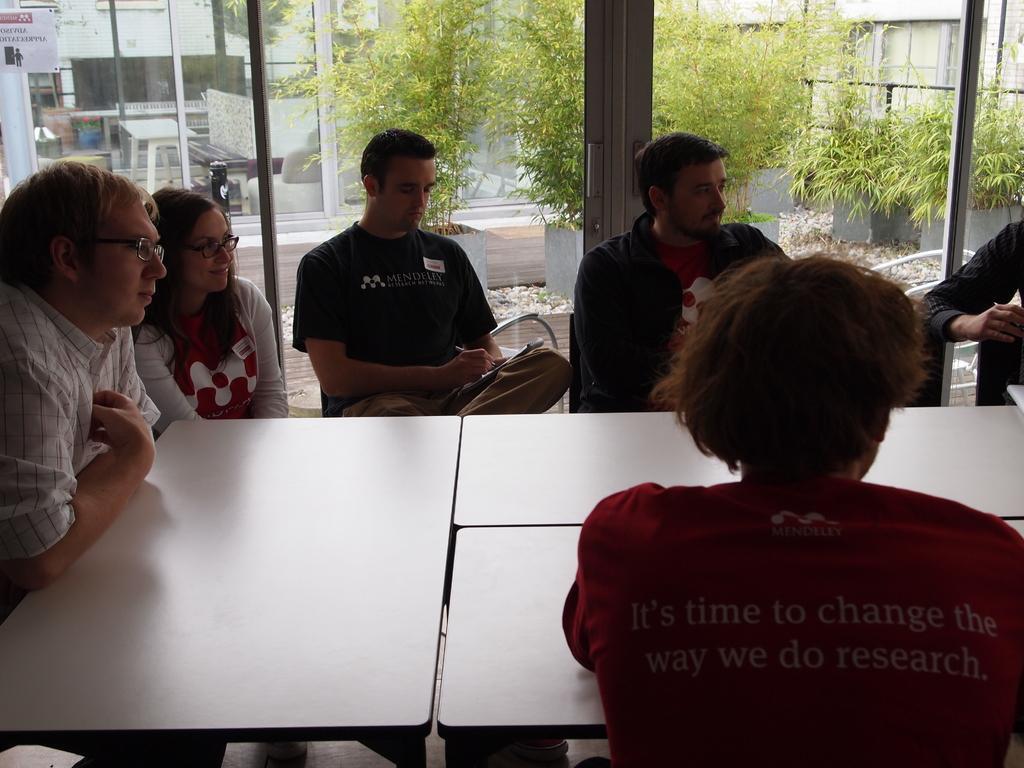In one or two sentences, can you explain what this image depicts? In this picture there are a group of people sitting and smiling, there is a window in the backdrop. 